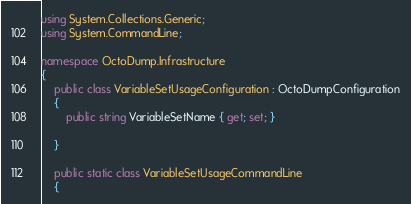Convert code to text. <code><loc_0><loc_0><loc_500><loc_500><_C#_>using System.Collections.Generic;
using System.CommandLine;

namespace OctoDump.Infrastructure
{
    public class VariableSetUsageConfiguration : OctoDumpConfiguration
    {
        public string VariableSetName { get; set; }

    }

    public static class VariableSetUsageCommandLine
    {</code> 